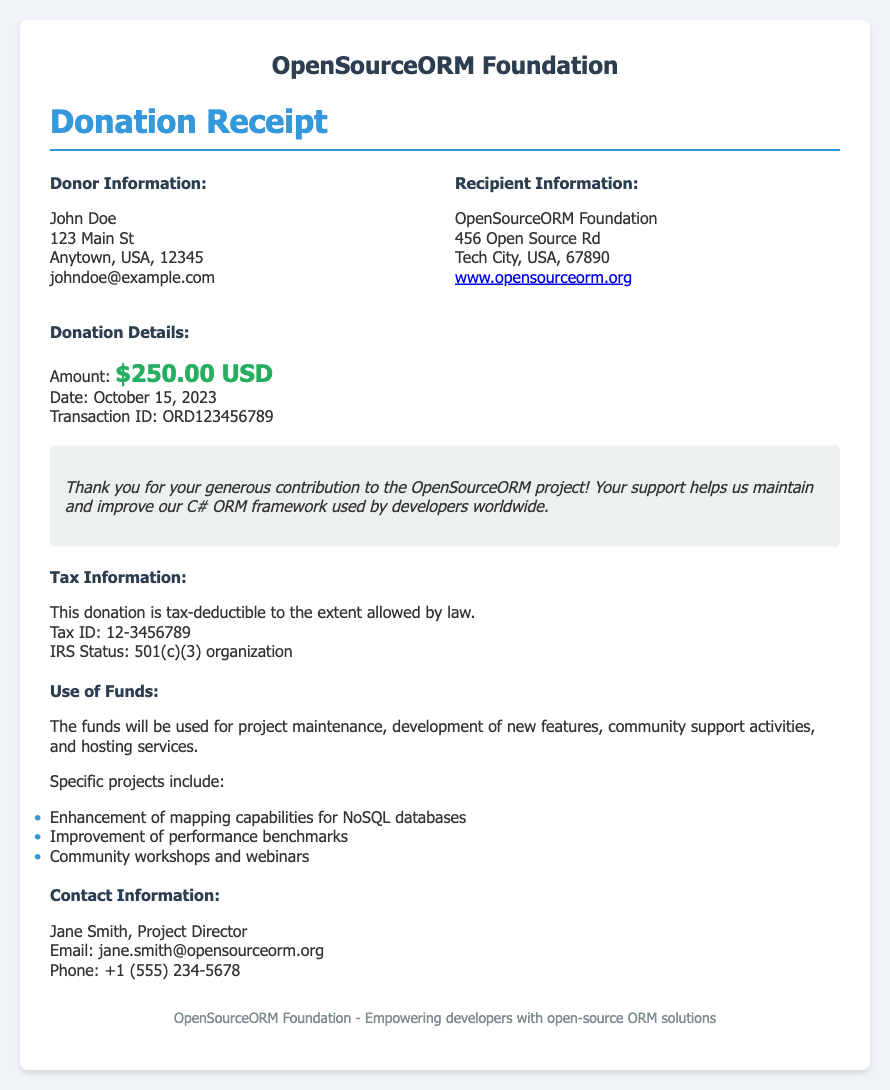What is the donor's name? The donor's name is specified in the Donor Information section of the document.
Answer: John Doe What is the donation amount? The donation amount is provided in the Donation Details section of the document.
Answer: $250.00 USD What is the donation date? The date of the donation is mentioned in the Donation Details section of the document.
Answer: October 15, 2023 What is the recipient's tax ID? The tax ID of the recipient organization is given in the Tax Information section of the document.
Answer: 12-3456789 What will the funds be used for? The purpose of the funds is outlined in the Use of Funds section, which lists specific aspects of the project.
Answer: project maintenance, development of new features, community support activities, and hosting services Who is the project director? The Project Director's name is indicated in the Contact Information section of the document.
Answer: Jane Smith What is the IRS status of the organization? The IRS status is specified in the Tax Information section and confirms the organization's classification.
Answer: 501(c)(3) organization What are some specific projects funded by the donation? The specific projects supported by the donation are listed in the Use of Funds section as examples.
Answer: Enhancement of mapping capabilities for NoSQL databases, Improvement of performance benchmarks, Community workshops and webinars What is the logo title of the organization? The logo title can be found at the top of the document under the header section.
Answer: OpenSourceORM Foundation 